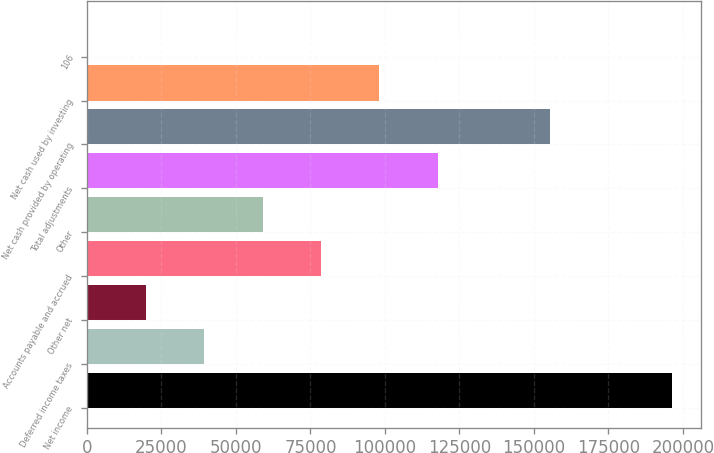Convert chart to OTSL. <chart><loc_0><loc_0><loc_500><loc_500><bar_chart><fcel>Net income<fcel>Deferred income taxes<fcel>Other net<fcel>Accounts payable and accrued<fcel>Other<fcel>Total adjustments<fcel>Net cash provided by operating<fcel>Net cash used by investing<fcel>106<nl><fcel>196202<fcel>39325.2<fcel>19715.6<fcel>78544.4<fcel>58934.8<fcel>117764<fcel>155285<fcel>98154<fcel>106<nl></chart> 